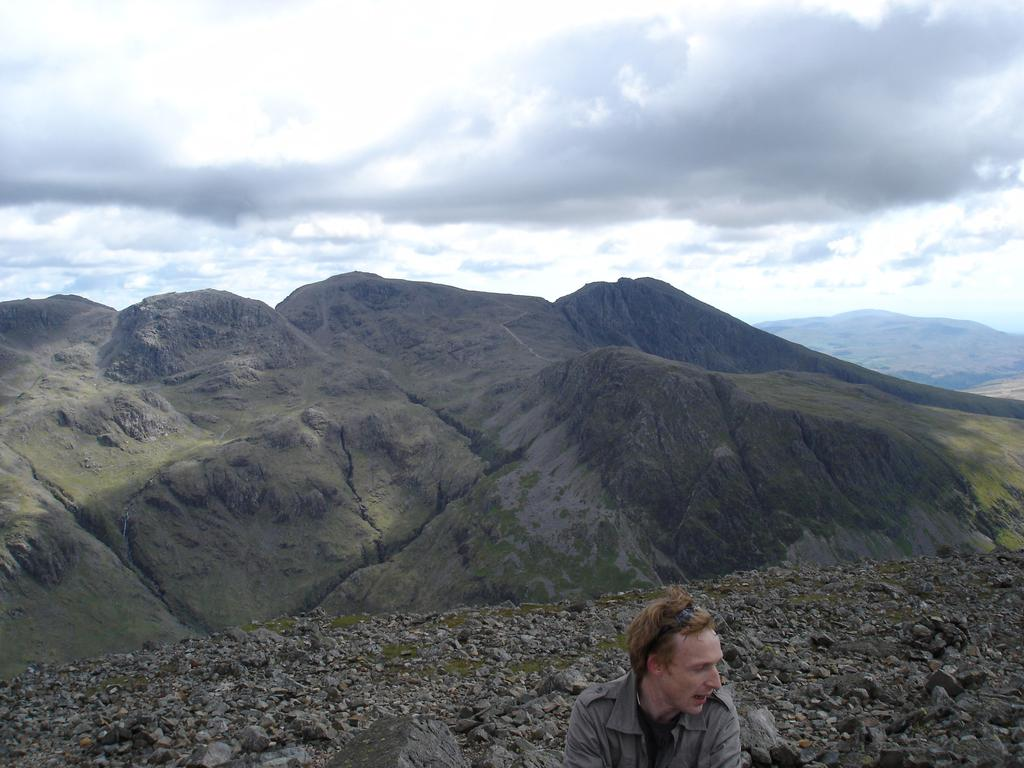Who or what is located at the front of the image? There is a person in the front of the image. What type of landscape can be seen in the background of the image? There are mountains in the background of the image. What is the condition of the sky in the image? The sky is cloudy in the image. What type of expansion is taking place in the image? There is no indication of any expansion in the image. Is the person in the image an achiever? The image does not provide any information about the person's achievements or accomplishments. 